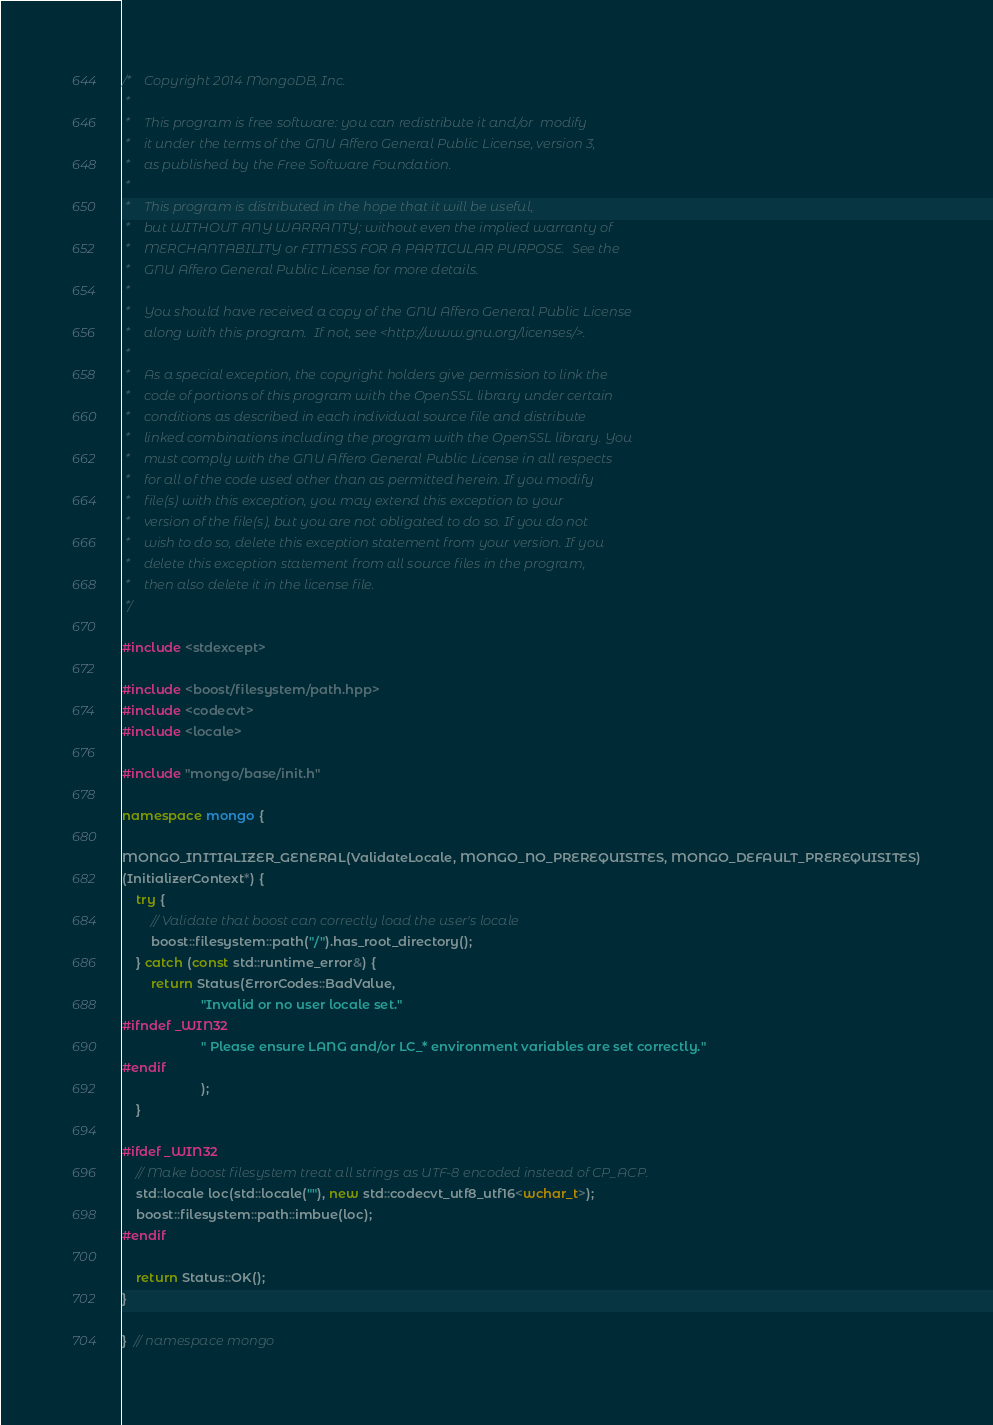Convert code to text. <code><loc_0><loc_0><loc_500><loc_500><_C++_>/*    Copyright 2014 MongoDB, Inc.
 *
 *    This program is free software: you can redistribute it and/or  modify
 *    it under the terms of the GNU Affero General Public License, version 3,
 *    as published by the Free Software Foundation.
 *
 *    This program is distributed in the hope that it will be useful,
 *    but WITHOUT ANY WARRANTY; without even the implied warranty of
 *    MERCHANTABILITY or FITNESS FOR A PARTICULAR PURPOSE.  See the
 *    GNU Affero General Public License for more details.
 *
 *    You should have received a copy of the GNU Affero General Public License
 *    along with this program.  If not, see <http://www.gnu.org/licenses/>.
 *
 *    As a special exception, the copyright holders give permission to link the
 *    code of portions of this program with the OpenSSL library under certain
 *    conditions as described in each individual source file and distribute
 *    linked combinations including the program with the OpenSSL library. You
 *    must comply with the GNU Affero General Public License in all respects
 *    for all of the code used other than as permitted herein. If you modify
 *    file(s) with this exception, you may extend this exception to your
 *    version of the file(s), but you are not obligated to do so. If you do not
 *    wish to do so, delete this exception statement from your version. If you
 *    delete this exception statement from all source files in the program,
 *    then also delete it in the license file.
 */

#include <stdexcept>

#include <boost/filesystem/path.hpp>
#include <codecvt>
#include <locale>

#include "mongo/base/init.h"

namespace mongo {

MONGO_INITIALIZER_GENERAL(ValidateLocale, MONGO_NO_PREREQUISITES, MONGO_DEFAULT_PREREQUISITES)
(InitializerContext*) {
    try {
        // Validate that boost can correctly load the user's locale
        boost::filesystem::path("/").has_root_directory();
    } catch (const std::runtime_error&) {
        return Status(ErrorCodes::BadValue,
                      "Invalid or no user locale set."
#ifndef _WIN32
                      " Please ensure LANG and/or LC_* environment variables are set correctly."
#endif
                      );
    }

#ifdef _WIN32
    // Make boost filesystem treat all strings as UTF-8 encoded instead of CP_ACP.
    std::locale loc(std::locale(""), new std::codecvt_utf8_utf16<wchar_t>);
    boost::filesystem::path::imbue(loc);
#endif

    return Status::OK();
}

}  // namespace mongo
</code> 